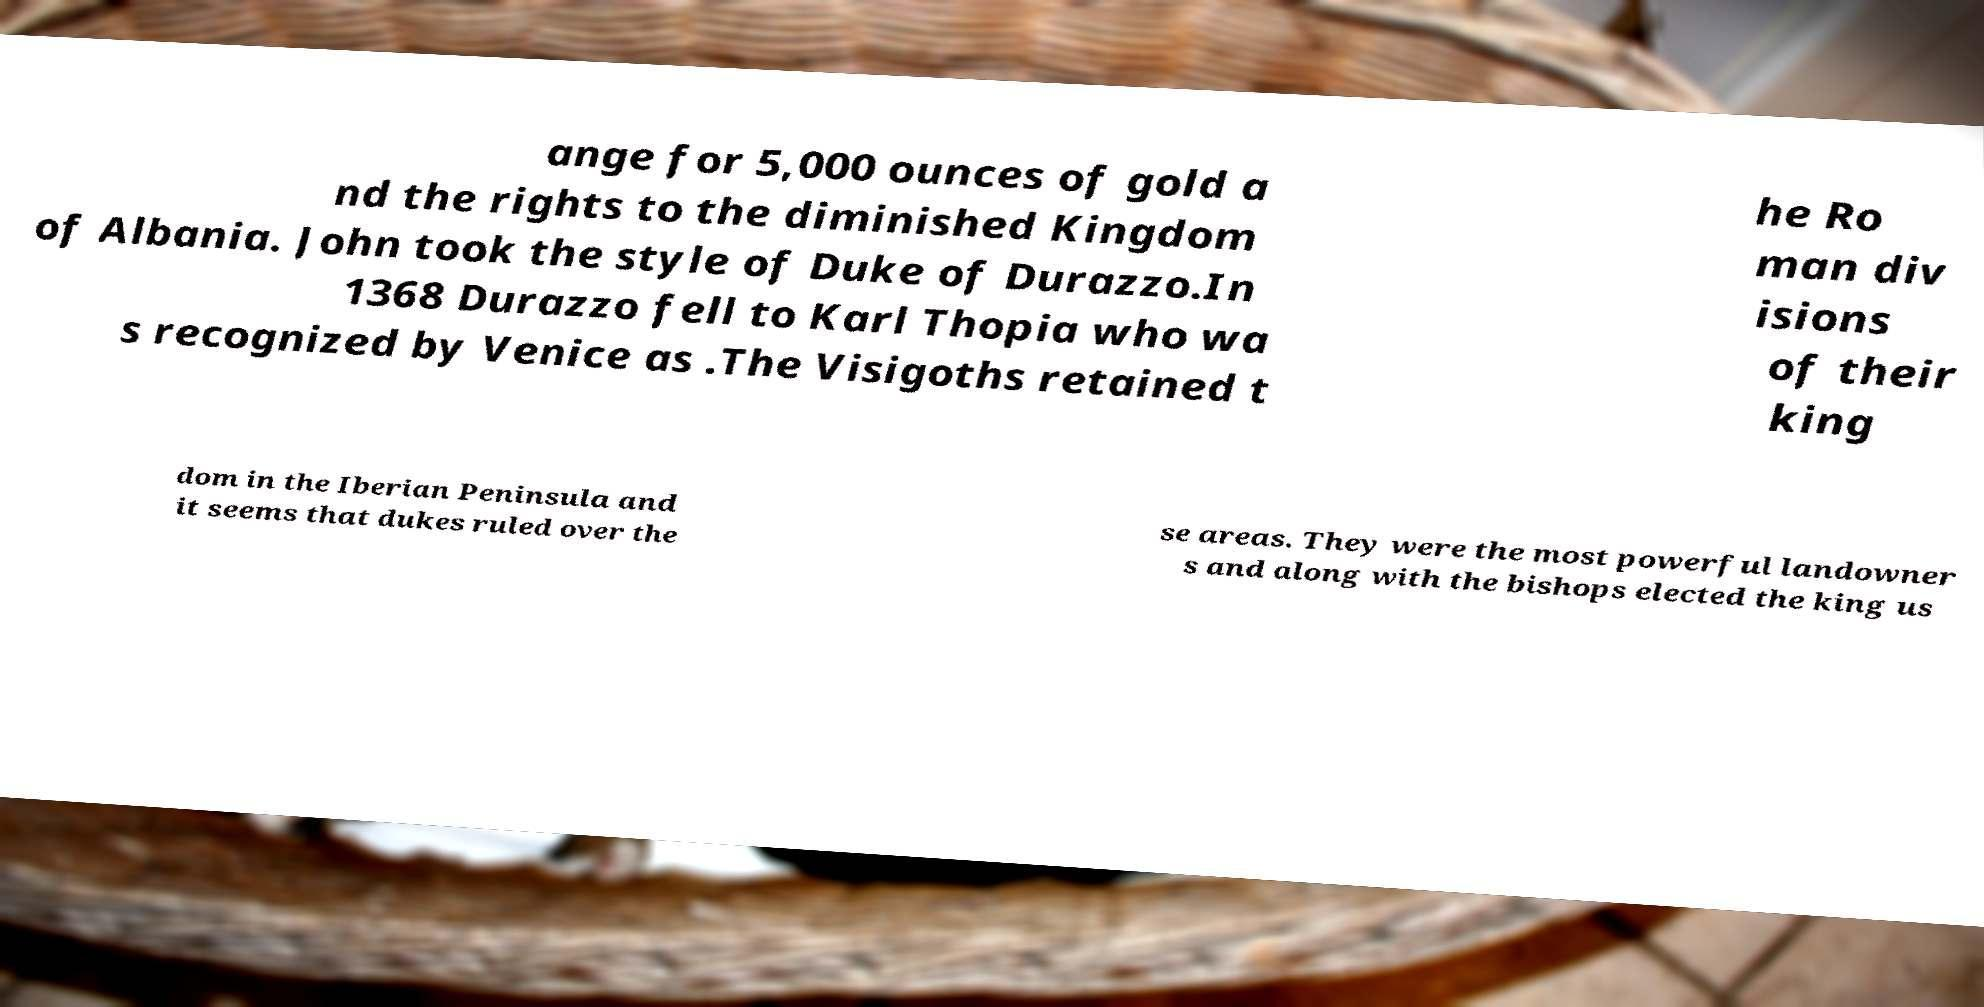Can you read and provide the text displayed in the image?This photo seems to have some interesting text. Can you extract and type it out for me? ange for 5,000 ounces of gold a nd the rights to the diminished Kingdom of Albania. John took the style of Duke of Durazzo.In 1368 Durazzo fell to Karl Thopia who wa s recognized by Venice as .The Visigoths retained t he Ro man div isions of their king dom in the Iberian Peninsula and it seems that dukes ruled over the se areas. They were the most powerful landowner s and along with the bishops elected the king us 